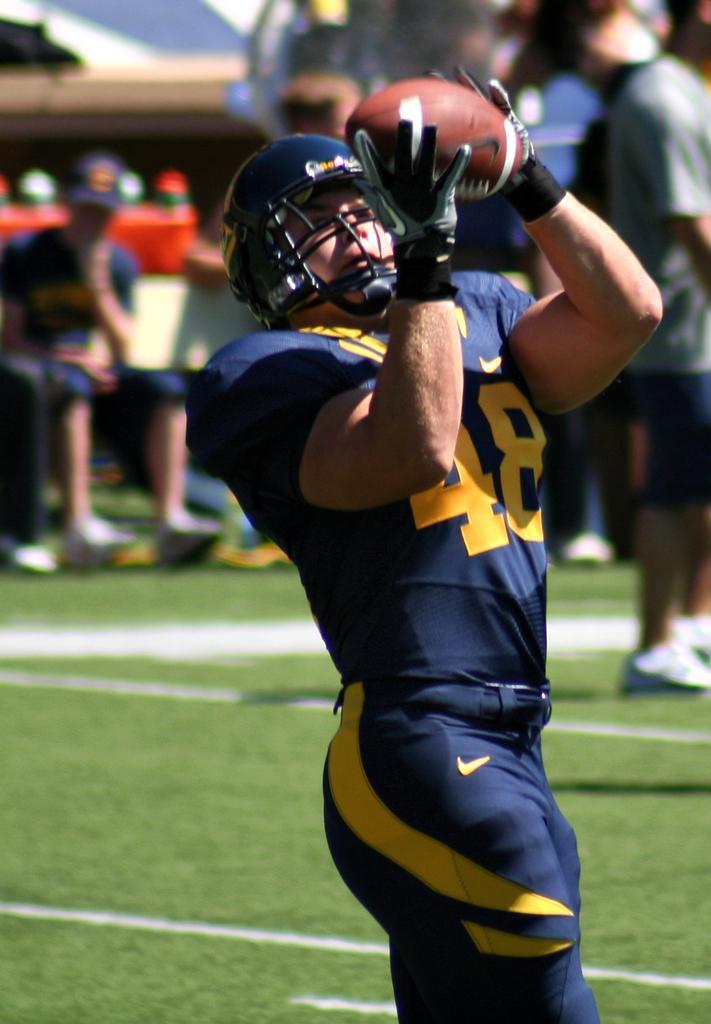Please provide a concise description of this image. In this picture we can see a man with a helmet is holding a ball and standing on the path. Behind the man there are some blurred people. 